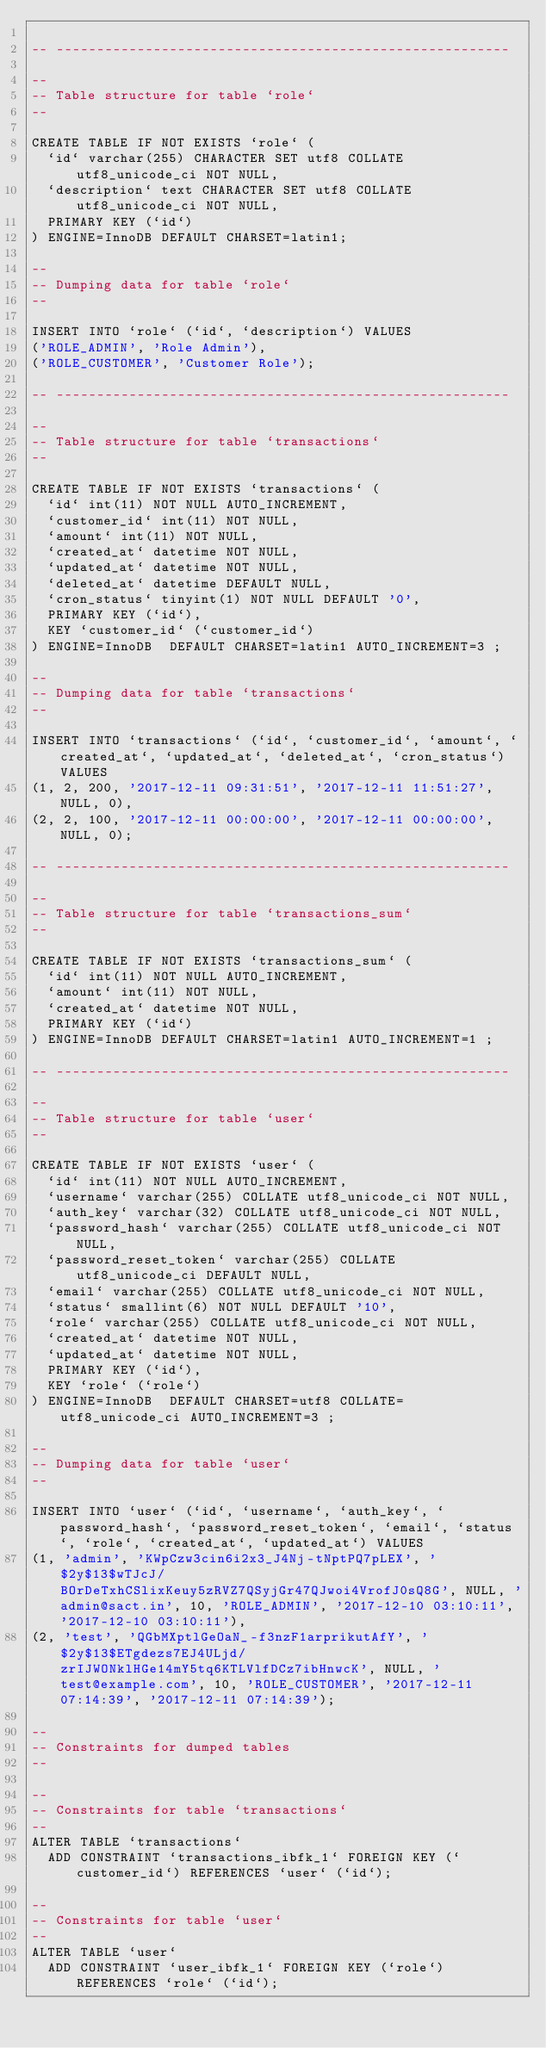<code> <loc_0><loc_0><loc_500><loc_500><_SQL_>
-- --------------------------------------------------------

--
-- Table structure for table `role`
--

CREATE TABLE IF NOT EXISTS `role` (
  `id` varchar(255) CHARACTER SET utf8 COLLATE utf8_unicode_ci NOT NULL,
  `description` text CHARACTER SET utf8 COLLATE utf8_unicode_ci NOT NULL,
  PRIMARY KEY (`id`)
) ENGINE=InnoDB DEFAULT CHARSET=latin1;

--
-- Dumping data for table `role`
--

INSERT INTO `role` (`id`, `description`) VALUES
('ROLE_ADMIN', 'Role Admin'),
('ROLE_CUSTOMER', 'Customer Role');

-- --------------------------------------------------------

--
-- Table structure for table `transactions`
--

CREATE TABLE IF NOT EXISTS `transactions` (
  `id` int(11) NOT NULL AUTO_INCREMENT,
  `customer_id` int(11) NOT NULL,
  `amount` int(11) NOT NULL,
  `created_at` datetime NOT NULL,
  `updated_at` datetime NOT NULL,
  `deleted_at` datetime DEFAULT NULL,
  `cron_status` tinyint(1) NOT NULL DEFAULT '0',
  PRIMARY KEY (`id`),
  KEY `customer_id` (`customer_id`)
) ENGINE=InnoDB  DEFAULT CHARSET=latin1 AUTO_INCREMENT=3 ;

--
-- Dumping data for table `transactions`
--

INSERT INTO `transactions` (`id`, `customer_id`, `amount`, `created_at`, `updated_at`, `deleted_at`, `cron_status`) VALUES
(1, 2, 200, '2017-12-11 09:31:51', '2017-12-11 11:51:27', NULL, 0),
(2, 2, 100, '2017-12-11 00:00:00', '2017-12-11 00:00:00', NULL, 0);

-- --------------------------------------------------------

--
-- Table structure for table `transactions_sum`
--

CREATE TABLE IF NOT EXISTS `transactions_sum` (
  `id` int(11) NOT NULL AUTO_INCREMENT,
  `amount` int(11) NOT NULL,
  `created_at` datetime NOT NULL,
  PRIMARY KEY (`id`)
) ENGINE=InnoDB DEFAULT CHARSET=latin1 AUTO_INCREMENT=1 ;

-- --------------------------------------------------------

--
-- Table structure for table `user`
--

CREATE TABLE IF NOT EXISTS `user` (
  `id` int(11) NOT NULL AUTO_INCREMENT,
  `username` varchar(255) COLLATE utf8_unicode_ci NOT NULL,
  `auth_key` varchar(32) COLLATE utf8_unicode_ci NOT NULL,
  `password_hash` varchar(255) COLLATE utf8_unicode_ci NOT NULL,
  `password_reset_token` varchar(255) COLLATE utf8_unicode_ci DEFAULT NULL,
  `email` varchar(255) COLLATE utf8_unicode_ci NOT NULL,
  `status` smallint(6) NOT NULL DEFAULT '10',
  `role` varchar(255) COLLATE utf8_unicode_ci NOT NULL,
  `created_at` datetime NOT NULL,
  `updated_at` datetime NOT NULL,
  PRIMARY KEY (`id`),
  KEY `role` (`role`)
) ENGINE=InnoDB  DEFAULT CHARSET=utf8 COLLATE=utf8_unicode_ci AUTO_INCREMENT=3 ;

--
-- Dumping data for table `user`
--

INSERT INTO `user` (`id`, `username`, `auth_key`, `password_hash`, `password_reset_token`, `email`, `status`, `role`, `created_at`, `updated_at`) VALUES
(1, 'admin', 'KWpCzw3cin6i2x3_J4Nj-tNptPQ7pLEX', '$2y$13$wTJcJ/BOrDeTxhCSlixKeuy5zRVZ7QSyjGr47QJwoi4VrofJ0sQ8G', NULL, 'admin@sact.in', 10, 'ROLE_ADMIN', '2017-12-10 03:10:11', '2017-12-10 03:10:11'),
(2, 'test', 'QGbMXptlGeOaN_-f3nzF1arprikutAfY', '$2y$13$ETgdezs7EJ4ULjd/zrIJWONklHGe14mY5tq6KTLVlfDCz7ibHnwcK', NULL, 'test@example.com', 10, 'ROLE_CUSTOMER', '2017-12-11 07:14:39', '2017-12-11 07:14:39');

--
-- Constraints for dumped tables
--

--
-- Constraints for table `transactions`
--
ALTER TABLE `transactions`
  ADD CONSTRAINT `transactions_ibfk_1` FOREIGN KEY (`customer_id`) REFERENCES `user` (`id`);

--
-- Constraints for table `user`
--
ALTER TABLE `user`
  ADD CONSTRAINT `user_ibfk_1` FOREIGN KEY (`role`) REFERENCES `role` (`id`);

</code> 